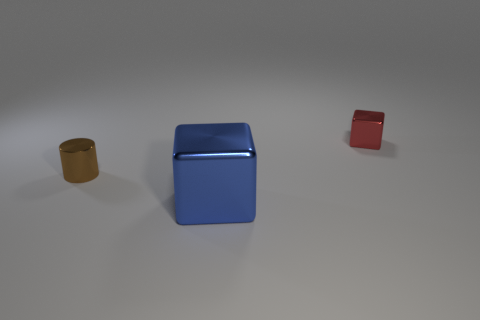Is there anything else that is the same shape as the small red metallic thing?
Provide a succinct answer. Yes. Is the tiny red block made of the same material as the small object that is left of the blue block?
Offer a very short reply. Yes. The cube that is behind the metal cube in front of the object that is left of the large block is what color?
Offer a very short reply. Red. Is there any other thing that has the same size as the blue shiny cube?
Offer a terse response. No. What color is the tiny block?
Provide a short and direct response. Red. The small metal thing that is on the right side of the metal block that is in front of the metal block that is behind the big metallic object is what shape?
Keep it short and to the point. Cube. What number of other objects are there of the same color as the tiny shiny cylinder?
Offer a terse response. 0. Are there more tiny brown cylinders in front of the cylinder than large cubes that are to the right of the large blue cube?
Your answer should be very brief. No. There is a blue object; are there any large metal blocks behind it?
Your answer should be compact. No. There is another metal thing that is the same shape as the red metal thing; what is its color?
Ensure brevity in your answer.  Blue. 